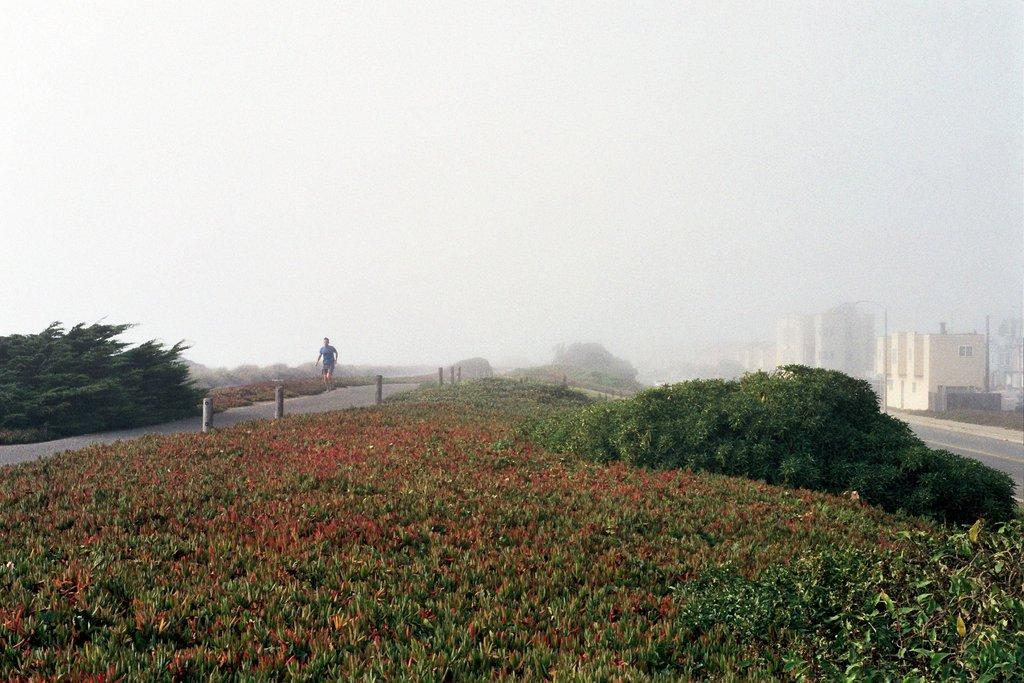What is the main subject in the image? There is a man standing in the image. What other elements can be seen in the image? There are plants, trees, houses, and the sky visible in the image. What type of lettuce is growing in the hall in the image? There is no hall or lettuce present in the image. 